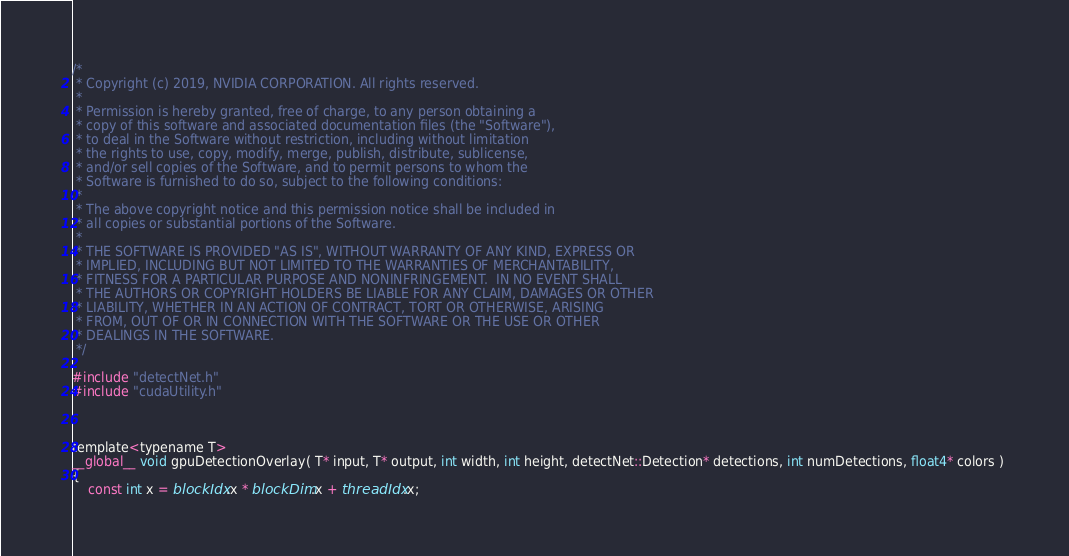<code> <loc_0><loc_0><loc_500><loc_500><_Cuda_>/*
 * Copyright (c) 2019, NVIDIA CORPORATION. All rights reserved.
 *
 * Permission is hereby granted, free of charge, to any person obtaining a
 * copy of this software and associated documentation files (the "Software"),
 * to deal in the Software without restriction, including without limitation
 * the rights to use, copy, modify, merge, publish, distribute, sublicense,
 * and/or sell copies of the Software, and to permit persons to whom the
 * Software is furnished to do so, subject to the following conditions:
 *
 * The above copyright notice and this permission notice shall be included in
 * all copies or substantial portions of the Software.
 *
 * THE SOFTWARE IS PROVIDED "AS IS", WITHOUT WARRANTY OF ANY KIND, EXPRESS OR
 * IMPLIED, INCLUDING BUT NOT LIMITED TO THE WARRANTIES OF MERCHANTABILITY,
 * FITNESS FOR A PARTICULAR PURPOSE AND NONINFRINGEMENT.  IN NO EVENT SHALL
 * THE AUTHORS OR COPYRIGHT HOLDERS BE LIABLE FOR ANY CLAIM, DAMAGES OR OTHER
 * LIABILITY, WHETHER IN AN ACTION OF CONTRACT, TORT OR OTHERWISE, ARISING
 * FROM, OUT OF OR IN CONNECTION WITH THE SOFTWARE OR THE USE OR OTHER
 * DEALINGS IN THE SOFTWARE.
 */

#include "detectNet.h"
#include "cudaUtility.h"



template<typename T>
__global__ void gpuDetectionOverlay( T* input, T* output, int width, int height, detectNet::Detection* detections, int numDetections, float4* colors ) 
{
	const int x = blockIdx.x * blockDim.x + threadIdx.x;</code> 